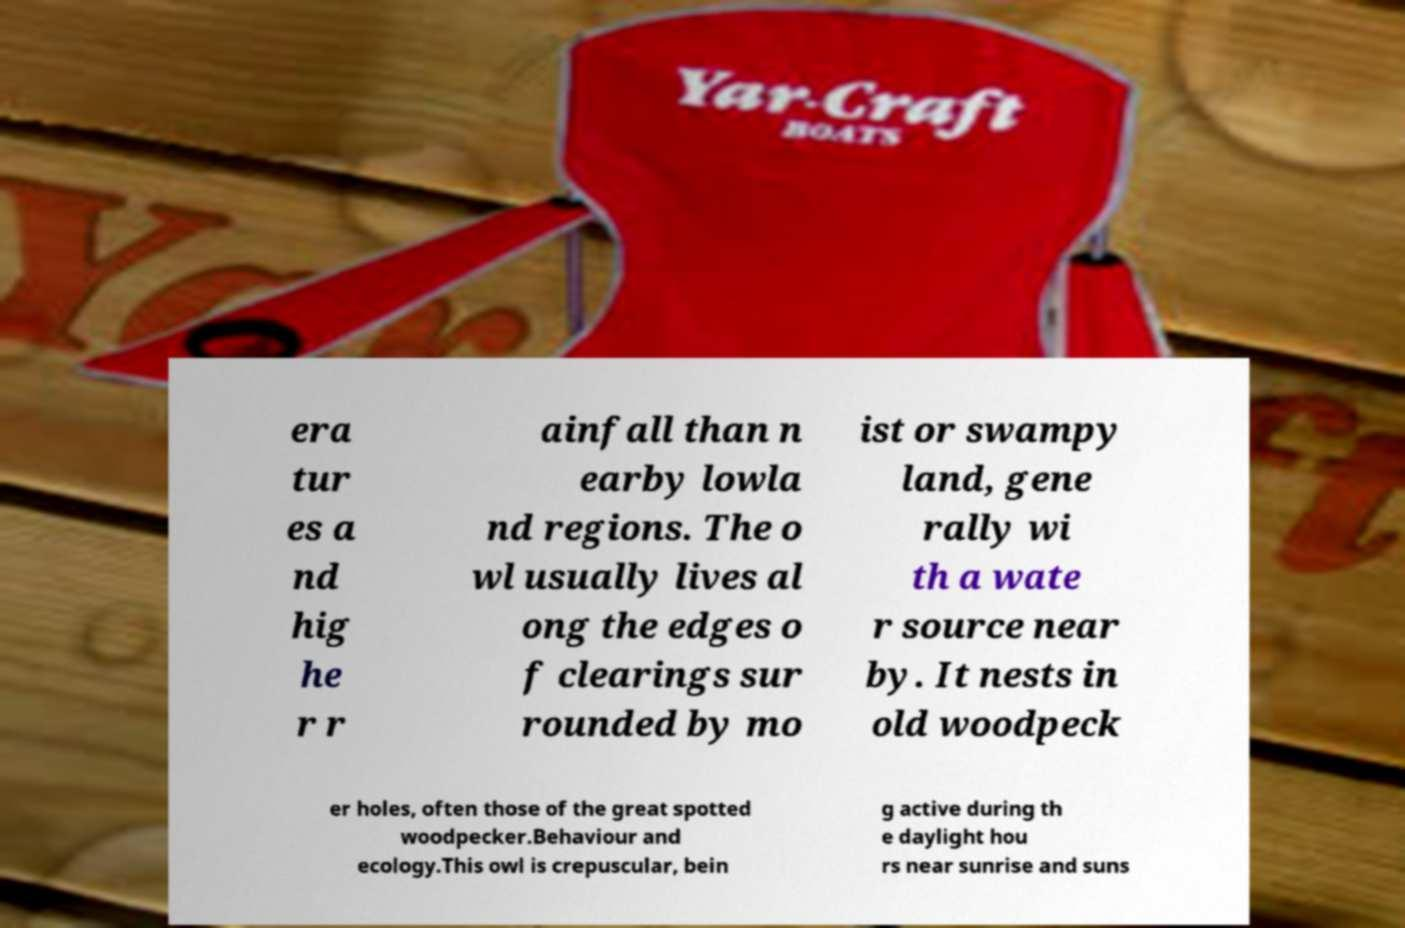I need the written content from this picture converted into text. Can you do that? era tur es a nd hig he r r ainfall than n earby lowla nd regions. The o wl usually lives al ong the edges o f clearings sur rounded by mo ist or swampy land, gene rally wi th a wate r source near by. It nests in old woodpeck er holes, often those of the great spotted woodpecker.Behaviour and ecology.This owl is crepuscular, bein g active during th e daylight hou rs near sunrise and suns 